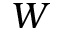<formula> <loc_0><loc_0><loc_500><loc_500>W</formula> 